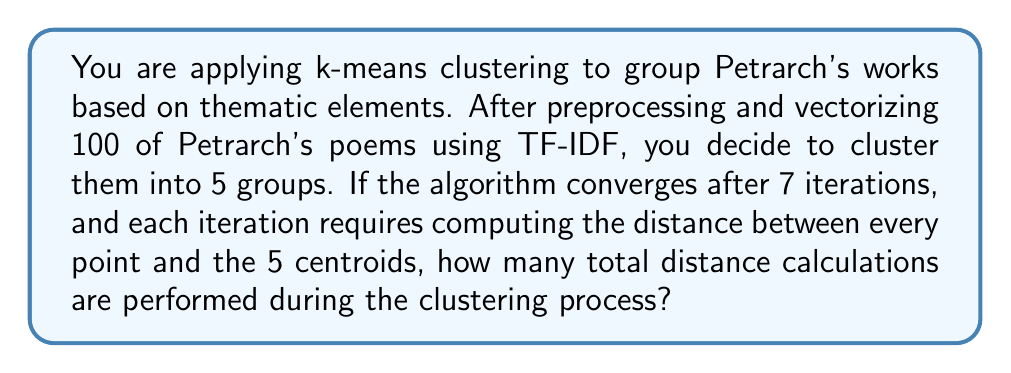Could you help me with this problem? To solve this problem, let's break it down step by step:

1. Understand the given information:
   - We have 100 poems (data points)
   - We are creating 5 clusters (k = 5)
   - The algorithm converges after 7 iterations

2. In each iteration of k-means:
   - Every data point needs to be compared to every centroid
   - Number of distance calculations per iteration = number of data points × number of centroids
   - In this case, that's 100 × 5 = 500 distance calculations per iteration

3. Calculate the total number of distance calculations:
   - Total calculations = (calculations per iteration) × (number of iterations)
   - In this case, that's 500 × 7 = 3500 distance calculations

The formula can be generalized as:

$$ \text{Total distance calculations} = n \times k \times i $$

Where:
$n$ = number of data points (poems)
$k$ = number of clusters
$i$ = number of iterations

In our case:
$$ \text{Total distance calculations} = 100 \times 5 \times 7 = 3500 $$
Answer: 3500 distance calculations 